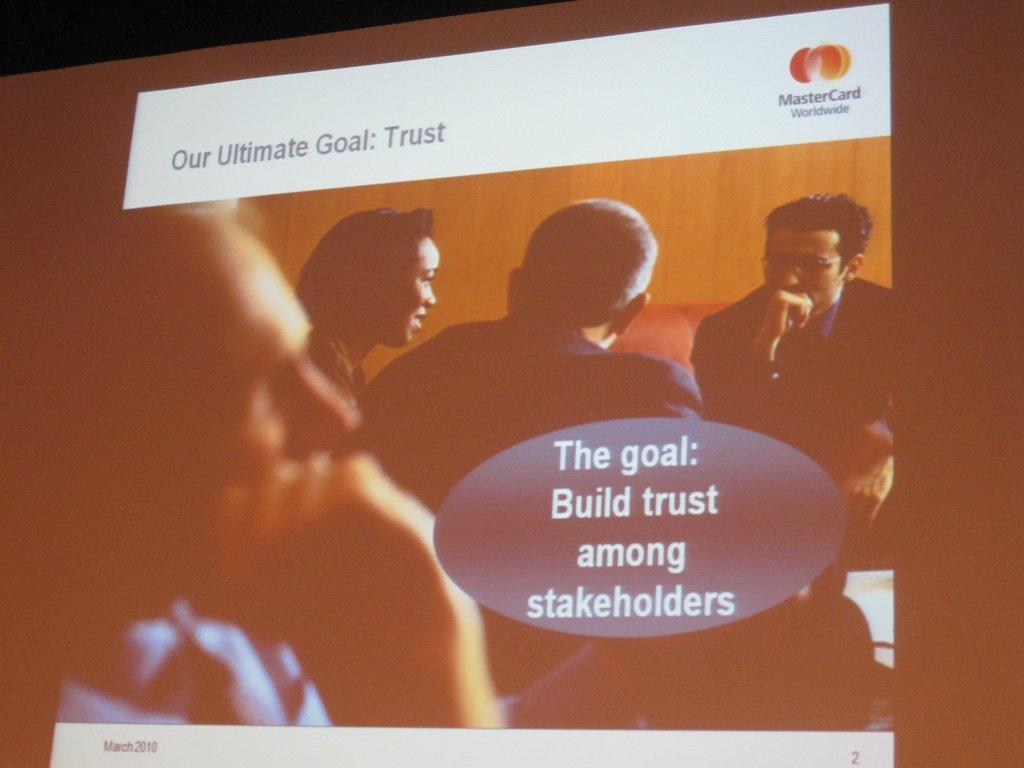What is the main object in the image? There is a screen in the image. What can be seen on the screen? There are persons visible on the screen. Are there any words or phrases visible on the screen? Yes, there is text visible on the screen. What type of debt is being discussed on the screen in the image? There is no mention of debt in the image; the screen displays persons and text. How many mittens are visible on the screen in the image? There are no mittens present on the screen in the image. 